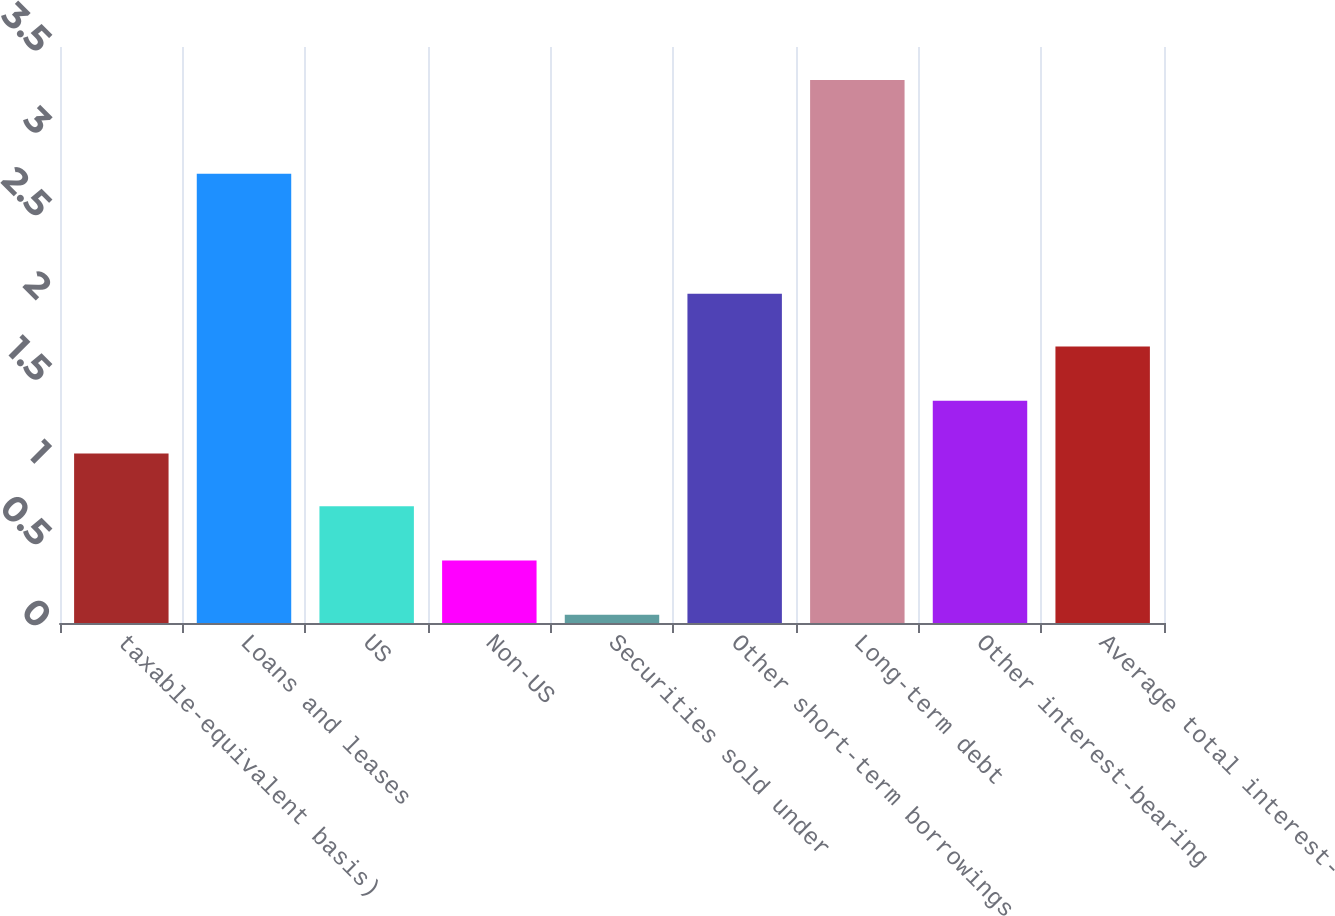Convert chart. <chart><loc_0><loc_0><loc_500><loc_500><bar_chart><fcel>taxable-equivalent basis)<fcel>Loans and leases<fcel>US<fcel>Non-US<fcel>Securities sold under<fcel>Other short-term borrowings<fcel>Long-term debt<fcel>Other interest-bearing<fcel>Average total interest-<nl><fcel>1.03<fcel>2.73<fcel>0.71<fcel>0.38<fcel>0.05<fcel>2<fcel>3.3<fcel>1.35<fcel>1.68<nl></chart> 